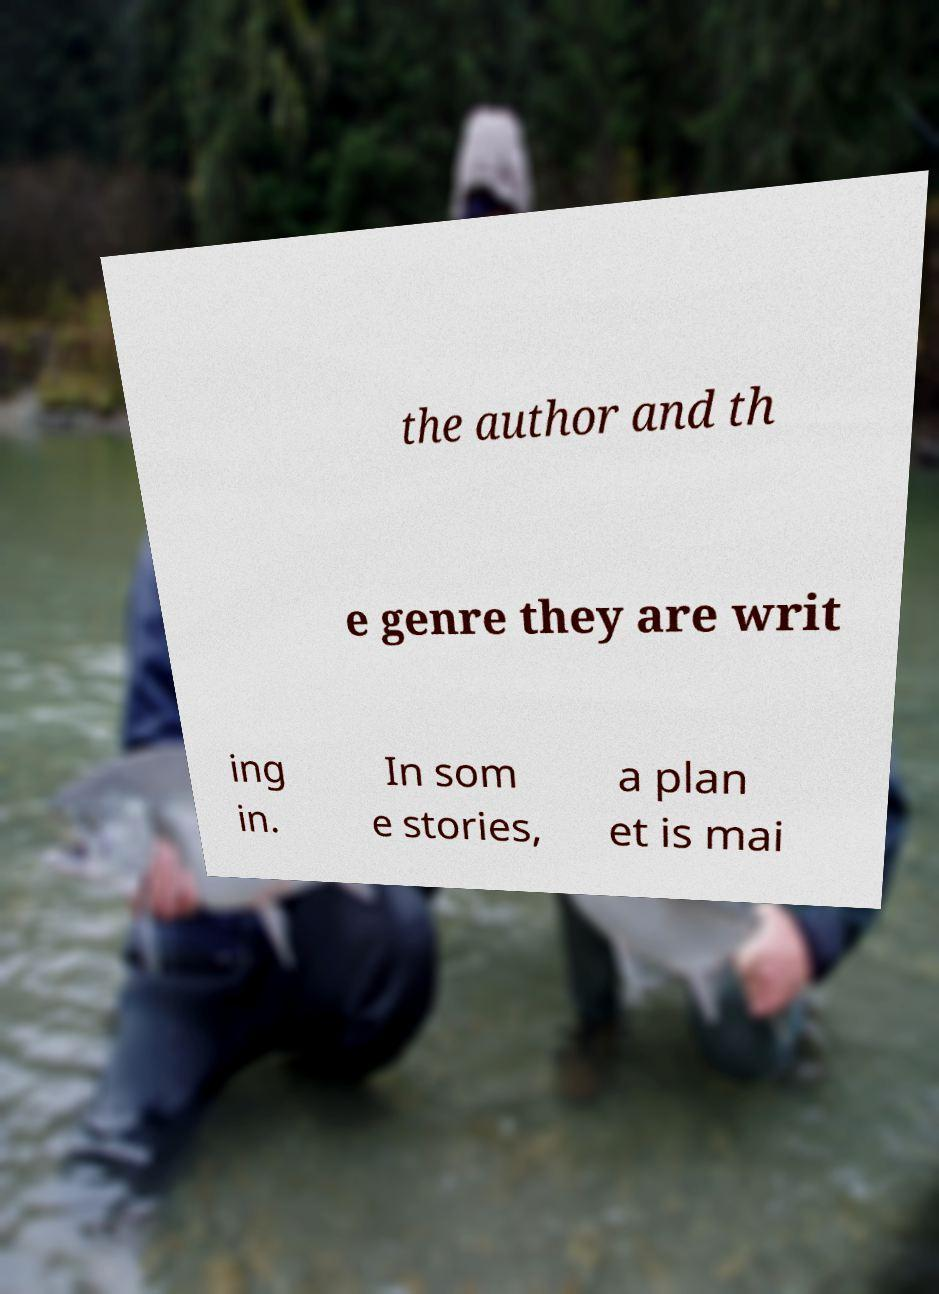What messages or text are displayed in this image? I need them in a readable, typed format. the author and th e genre they are writ ing in. In som e stories, a plan et is mai 